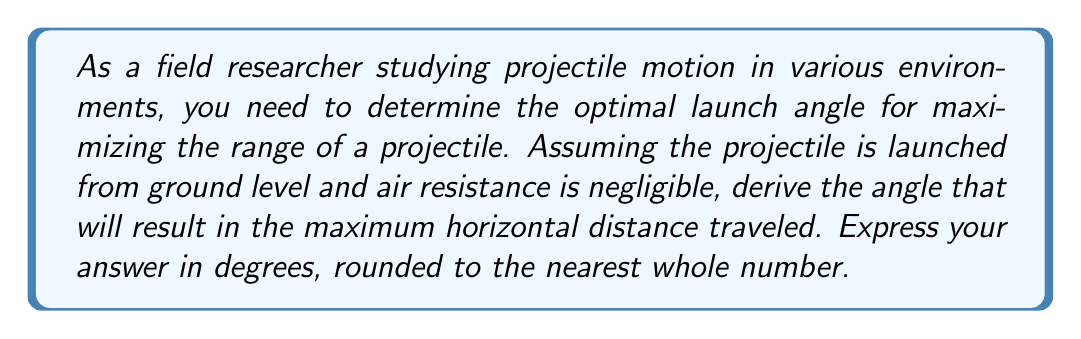Solve this math problem. Let's approach this step-by-step:

1) The range (R) of a projectile launched from ground level is given by the equation:

   $$R = \frac{v_0^2 \sin(2\theta)}{g}$$

   Where $v_0$ is the initial velocity, $\theta$ is the launch angle, and $g$ is the acceleration due to gravity.

2) To find the maximum range, we need to maximize $\sin(2\theta)$. The sine function reaches its maximum value of 1 when its argument is 90°.

3) Therefore, we want:

   $$2\theta = 90°$$

4) Solving for $\theta$:

   $$\theta = \frac{90°}{2} = 45°$$

5) We can verify this mathematically by taking the derivative of the range equation with respect to $\theta$, setting it to zero, and solving for $\theta$:

   $$\frac{dR}{d\theta} = \frac{v_0^2}{g} \cdot 2\cos(2\theta) = 0$$

   $$\cos(2\theta) = 0$$

   This occurs when $2\theta = 90°$, confirming our result.

6) Rounding to the nearest whole number:

   $45°$ (no rounding needed)

Therefore, the optimal angle for maximizing the range of a projectile is 45°.
Answer: 45° 